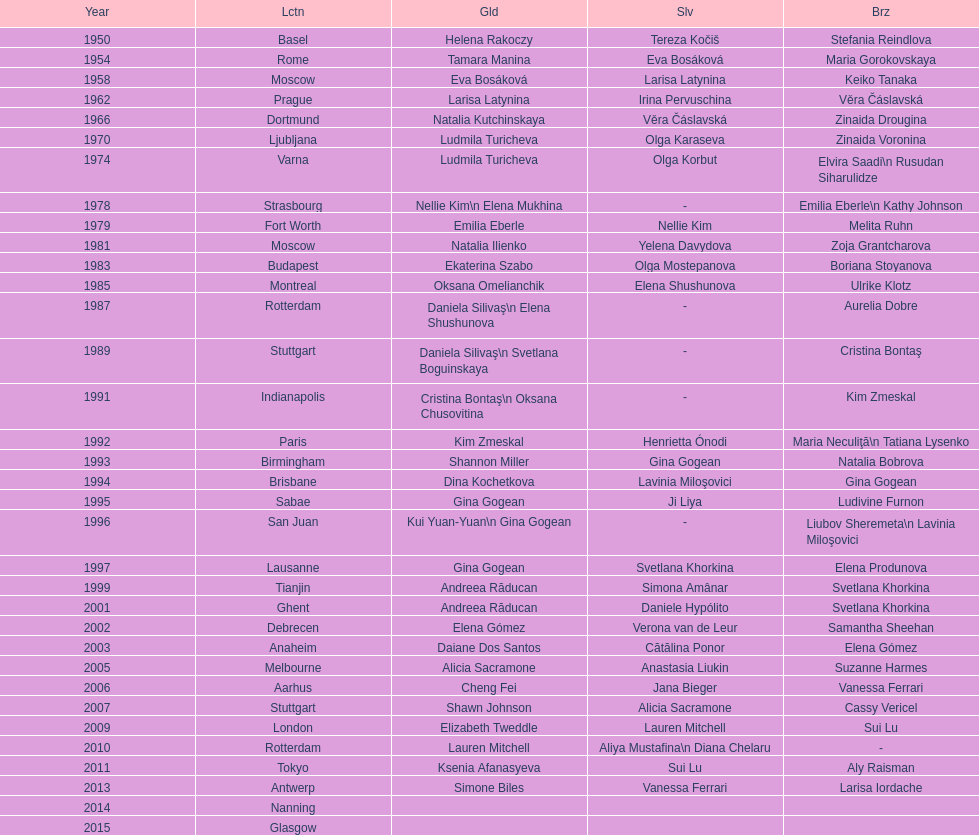Where did the world artistic gymnastics take place before san juan? Sabae. 